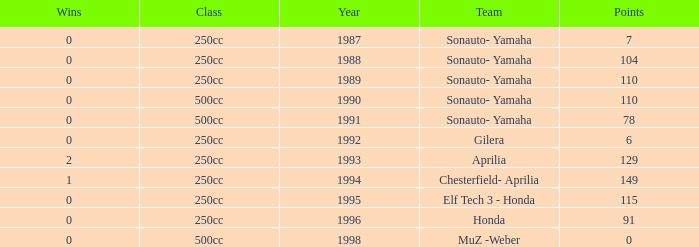How many wins did the team, which had more than 110 points, have in 1989? None. 